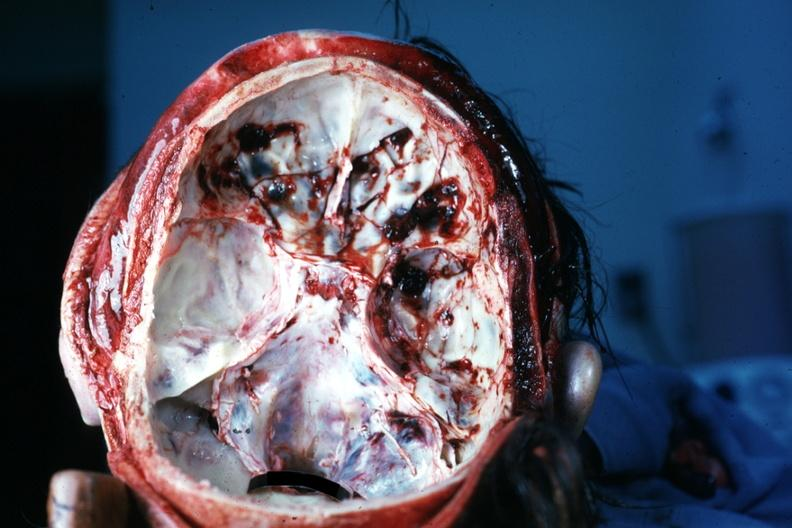s basilar skull fracture present?
Answer the question using a single word or phrase. Yes 